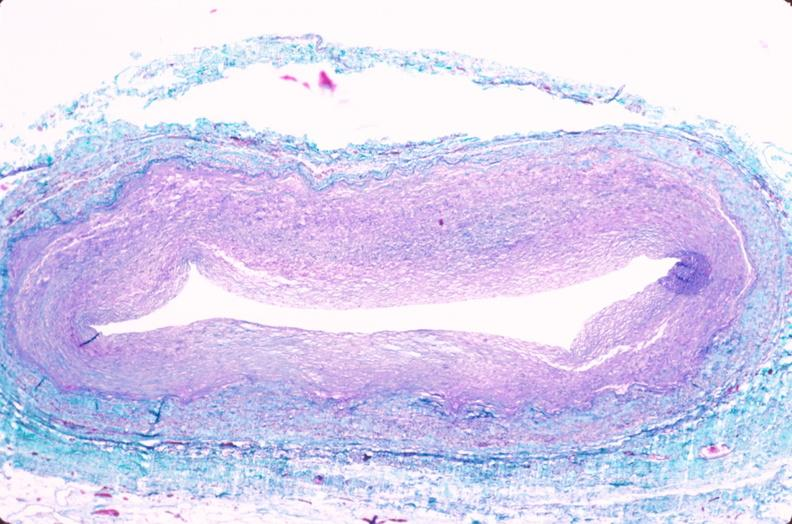what is present?
Answer the question using a single word or phrase. Vasculature 